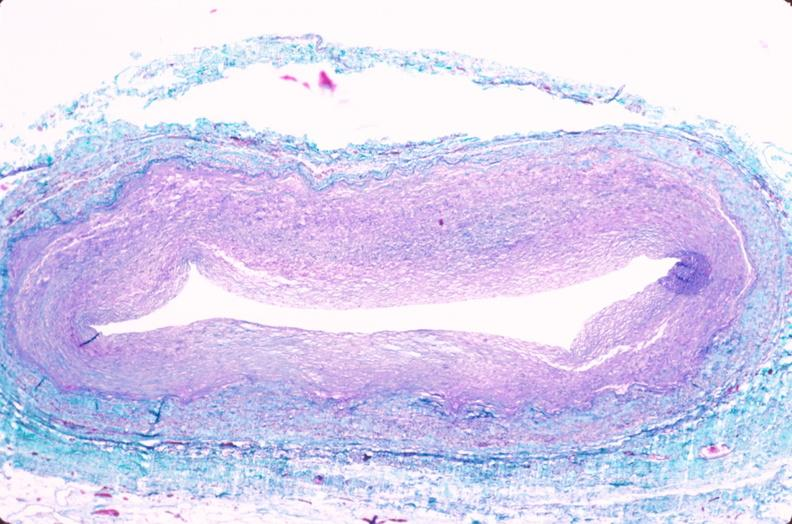what is present?
Answer the question using a single word or phrase. Vasculature 